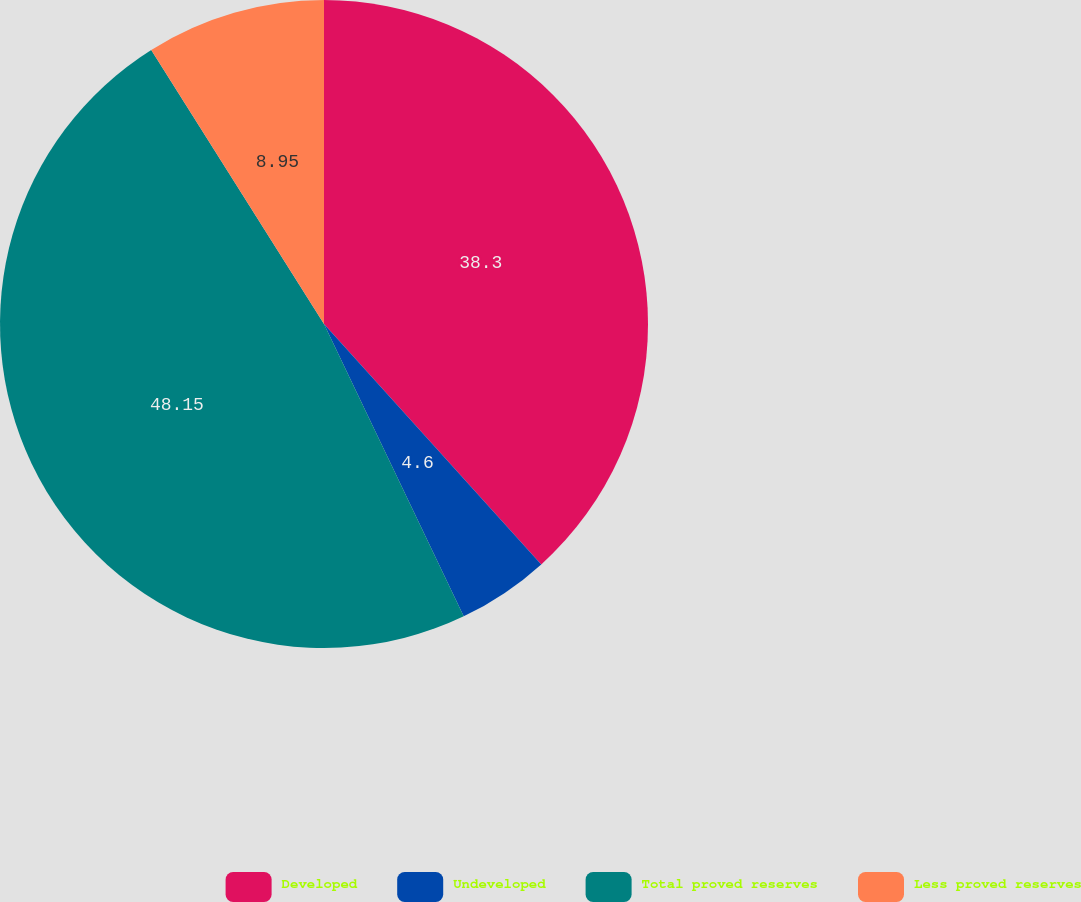Convert chart to OTSL. <chart><loc_0><loc_0><loc_500><loc_500><pie_chart><fcel>Developed<fcel>Undeveloped<fcel>Total proved reserves<fcel>Less proved reserves<nl><fcel>38.3%<fcel>4.6%<fcel>48.14%<fcel>8.95%<nl></chart> 